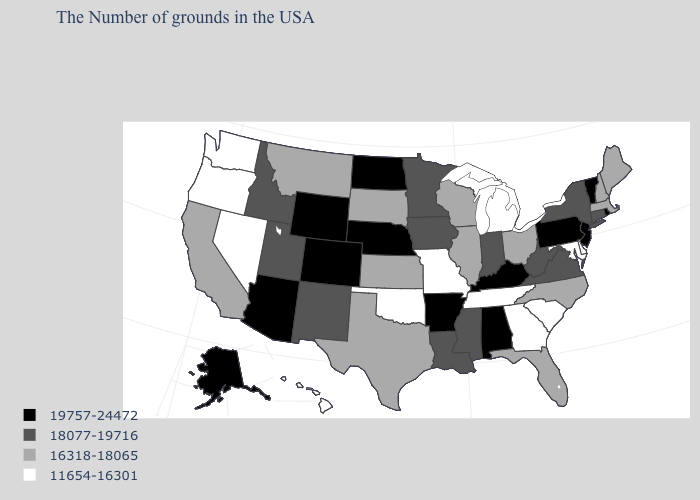Name the states that have a value in the range 11654-16301?
Concise answer only. Delaware, Maryland, South Carolina, Georgia, Michigan, Tennessee, Missouri, Oklahoma, Nevada, Washington, Oregon, Hawaii. Which states have the highest value in the USA?
Keep it brief. Rhode Island, Vermont, New Jersey, Pennsylvania, Kentucky, Alabama, Arkansas, Nebraska, North Dakota, Wyoming, Colorado, Arizona, Alaska. Which states have the lowest value in the USA?
Quick response, please. Delaware, Maryland, South Carolina, Georgia, Michigan, Tennessee, Missouri, Oklahoma, Nevada, Washington, Oregon, Hawaii. Does Kentucky have the highest value in the USA?
Quick response, please. Yes. Name the states that have a value in the range 19757-24472?
Be succinct. Rhode Island, Vermont, New Jersey, Pennsylvania, Kentucky, Alabama, Arkansas, Nebraska, North Dakota, Wyoming, Colorado, Arizona, Alaska. Name the states that have a value in the range 19757-24472?
Answer briefly. Rhode Island, Vermont, New Jersey, Pennsylvania, Kentucky, Alabama, Arkansas, Nebraska, North Dakota, Wyoming, Colorado, Arizona, Alaska. Does Indiana have the lowest value in the USA?
Keep it brief. No. Which states have the lowest value in the USA?
Write a very short answer. Delaware, Maryland, South Carolina, Georgia, Michigan, Tennessee, Missouri, Oklahoma, Nevada, Washington, Oregon, Hawaii. Does Arkansas have the highest value in the USA?
Answer briefly. Yes. What is the value of Alaska?
Give a very brief answer. 19757-24472. Does Vermont have the lowest value in the Northeast?
Be succinct. No. What is the lowest value in states that border Idaho?
Give a very brief answer. 11654-16301. Does Minnesota have the same value as West Virginia?
Short answer required. Yes. What is the value of Arkansas?
Short answer required. 19757-24472. 